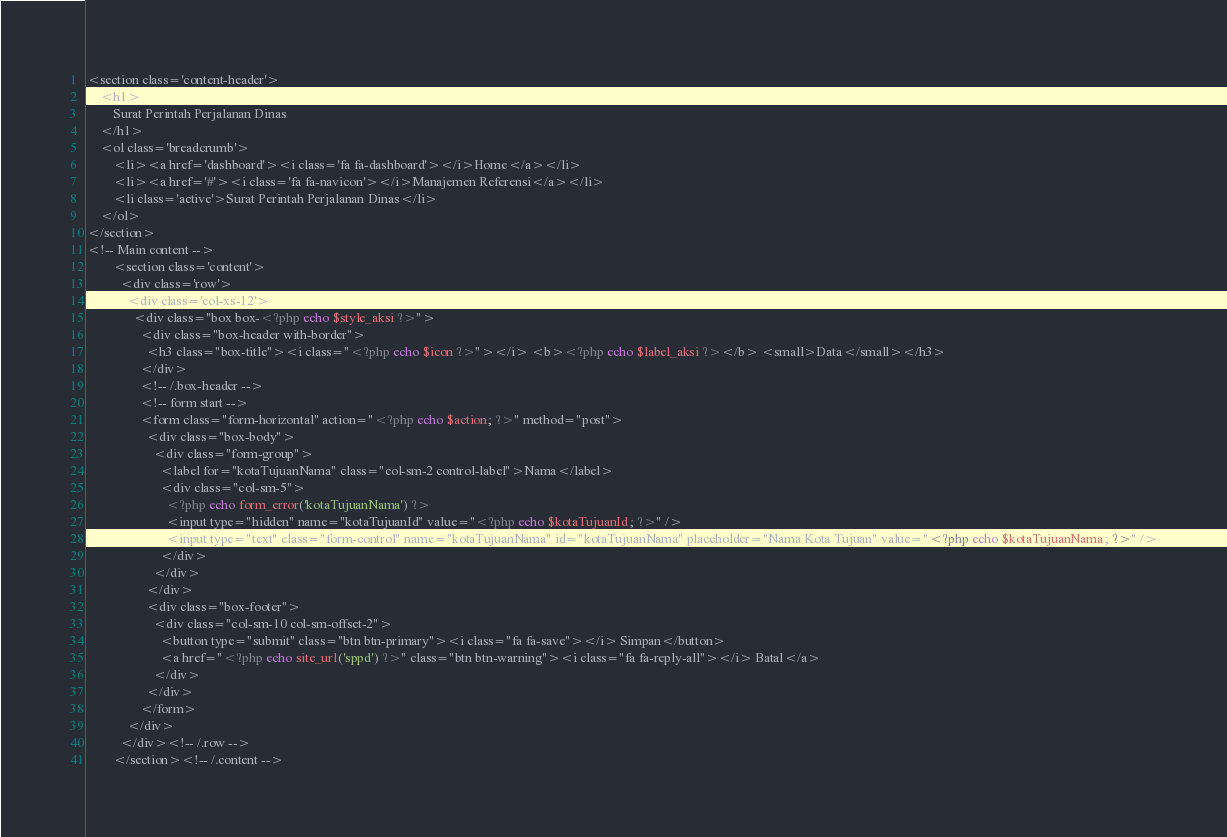Convert code to text. <code><loc_0><loc_0><loc_500><loc_500><_PHP_><section class='content-header'>
    <h1>
        Surat Perintah Perjalanan Dinas
    </h1>
    <ol class='breadcrumb'>
        <li><a href='dashboard'><i class='fa fa-dashboard'></i>Home</a></li>
        <li><a href='#'><i class='fa fa-navicon'></i>Manajemen Referensi</a></li>
        <li class='active'>Surat Perintah Perjalanan Dinas</li>
    </ol>
</section> 
<!-- Main content -->
        <section class='content'>
          <div class='row'>
            <div class='col-xs-12'>
              <div class="box box-<?php echo $style_aksi ?>">
                <div class="box-header with-border">
                  <h3 class="box-title"><i class="<?php echo $icon ?>"></i> <b><?php echo $label_aksi ?></b> <small>Data</small></h3>
                </div>
                <!-- /.box-header -->
                <!-- form start -->
                <form class="form-horizontal" action="<?php echo $action; ?>" method="post">
                  <div class="box-body">
                    <div class="form-group">
                      <label for="kotaTujuanNama" class="col-sm-2 control-label">Nama</label>
                      <div class="col-sm-5">
                        <?php echo form_error('kotaTujuanNama') ?>
                        <input type="hidden" name="kotaTujuanId" value="<?php echo $kotaTujuanId; ?>" /> 
                        <input type="text" class="form-control" name="kotaTujuanNama" id="kotaTujuanNama" placeholder="Nama Kota Tujuan" value="<?php echo $kotaTujuanNama; ?>" />
                      </div>
                    </div>
                  </div>
                  <div class="box-footer">
                    <div class="col-sm-10 col-sm-offset-2">
                      <button type="submit" class="btn btn-primary"><i class="fa fa-save"></i> Simpan</button> 
                      <a href="<?php echo site_url('sppd') ?>" class="btn btn-warning"><i class="fa fa-reply-all"></i> Batal</a>
                    </div>
                  </div>
                </form>
            </div>
          </div><!-- /.row -->
        </section><!-- /.content --></code> 